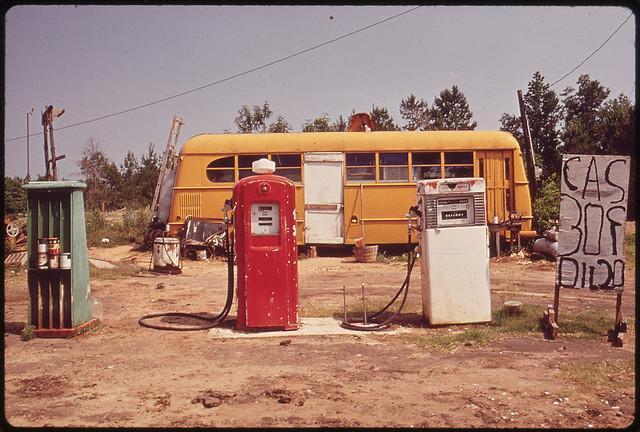How many horses are pulling the plow?
Give a very brief answer. 0. 